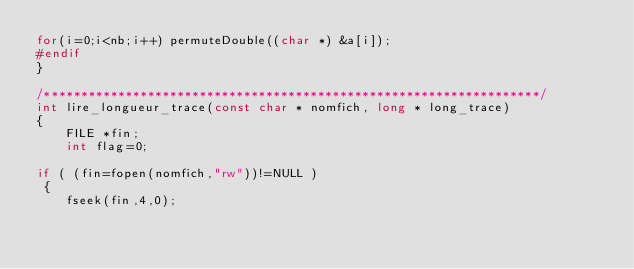Convert code to text. <code><loc_0><loc_0><loc_500><loc_500><_C_>for(i=0;i<nb;i++) permuteDouble((char *) &a[i]);
#endif
}

/*******************************************************************/
int lire_longueur_trace(const char * nomfich, long * long_trace)
{
    FILE *fin;
    int flag=0;

if ( (fin=fopen(nomfich,"rw"))!=NULL )
 {  
    fseek(fin,4,0);</code> 